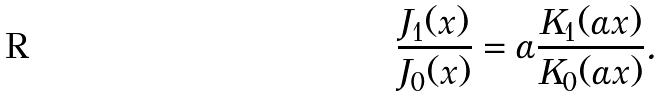Convert formula to latex. <formula><loc_0><loc_0><loc_500><loc_500>\frac { J _ { 1 } ( x ) } { J _ { 0 } ( x ) } = \alpha \frac { K _ { 1 } ( \alpha x ) } { K _ { 0 } ( \alpha x ) } .</formula> 